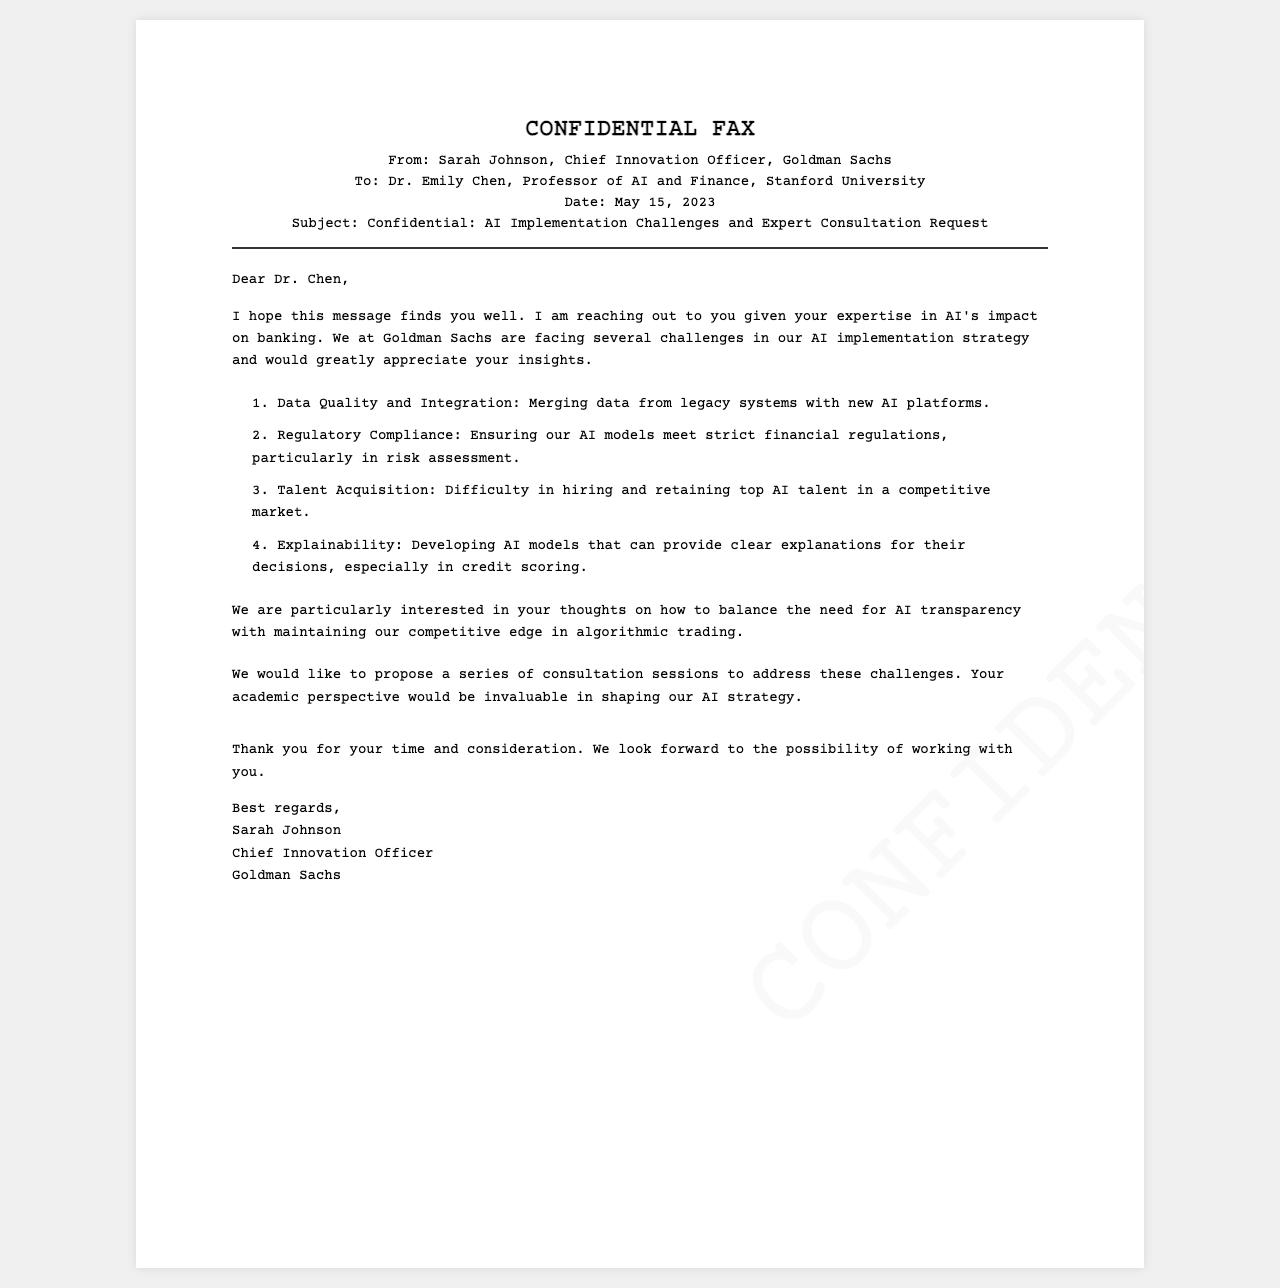What is the name of the sender? The sender is Sarah Johnson, Chief Innovation Officer at Goldman Sachs.
Answer: Sarah Johnson What is the date of the fax? The fax was sent on May 15, 2023.
Answer: May 15, 2023 What is one of the main challenges mentioned? One challenge mentioned is the difficulty in hiring and retaining top AI talent.
Answer: Talent Acquisition Who is the recipient of the fax? The fax is addressed to Dr. Emily Chen, Professor of AI and Finance at Stanford University.
Answer: Dr. Emily Chen What industry is Goldman Sachs associated with? Goldman Sachs is associated with the banking industry.
Answer: Banking What is the subject of the fax? The subject of the fax is "Confidential: AI Implementation Challenges and Expert Consultation Request."
Answer: Confidential: AI Implementation Challenges and Expert Consultation Request What type of expert consultation does Goldman Sachs seek? They seek insights regarding AI implementation strategies and transparency.
Answer: AI implementation strategies What does Goldman Sachs propose to address their challenges? They propose a series of consultation sessions with Dr. Chen.
Answer: Consultation sessions What is the focus regarding AI models in the specific request? The focus is on balancing AI transparency with maintaining a competitive edge.
Answer: AI transparency 